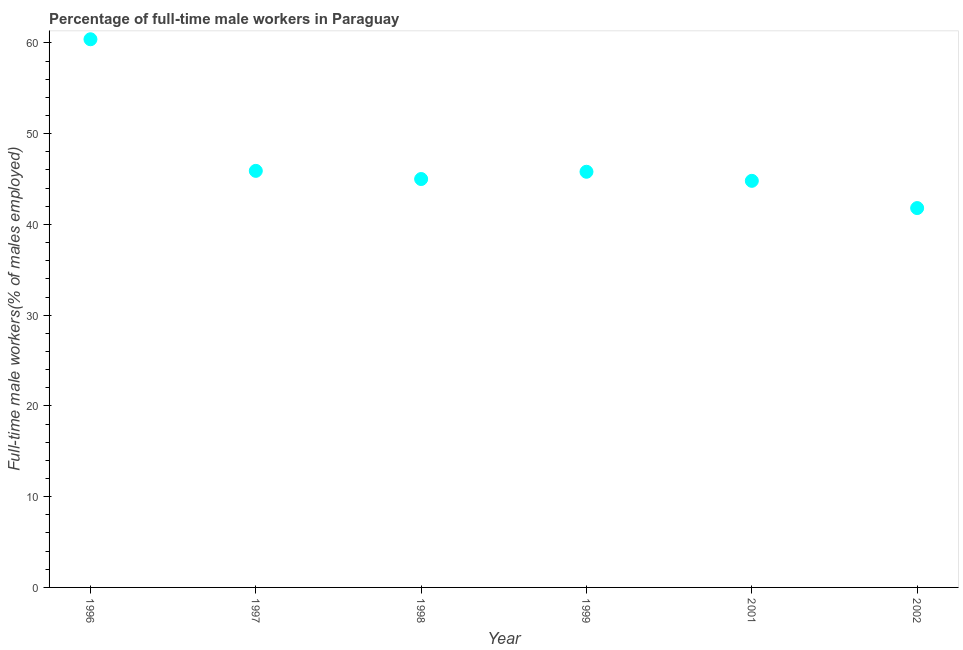What is the percentage of full-time male workers in 1996?
Ensure brevity in your answer.  60.4. Across all years, what is the maximum percentage of full-time male workers?
Provide a short and direct response. 60.4. Across all years, what is the minimum percentage of full-time male workers?
Make the answer very short. 41.8. In which year was the percentage of full-time male workers maximum?
Provide a succinct answer. 1996. What is the sum of the percentage of full-time male workers?
Offer a terse response. 283.7. What is the average percentage of full-time male workers per year?
Offer a terse response. 47.28. What is the median percentage of full-time male workers?
Offer a very short reply. 45.4. Do a majority of the years between 1999 and 2002 (inclusive) have percentage of full-time male workers greater than 14 %?
Keep it short and to the point. Yes. What is the ratio of the percentage of full-time male workers in 2001 to that in 2002?
Your answer should be compact. 1.07. What is the difference between the highest and the second highest percentage of full-time male workers?
Make the answer very short. 14.5. Is the sum of the percentage of full-time male workers in 1997 and 1999 greater than the maximum percentage of full-time male workers across all years?
Offer a terse response. Yes. What is the difference between the highest and the lowest percentage of full-time male workers?
Keep it short and to the point. 18.6. In how many years, is the percentage of full-time male workers greater than the average percentage of full-time male workers taken over all years?
Offer a very short reply. 1. How many dotlines are there?
Your answer should be very brief. 1. How many years are there in the graph?
Give a very brief answer. 6. What is the difference between two consecutive major ticks on the Y-axis?
Make the answer very short. 10. What is the title of the graph?
Ensure brevity in your answer.  Percentage of full-time male workers in Paraguay. What is the label or title of the X-axis?
Provide a short and direct response. Year. What is the label or title of the Y-axis?
Your answer should be compact. Full-time male workers(% of males employed). What is the Full-time male workers(% of males employed) in 1996?
Your answer should be very brief. 60.4. What is the Full-time male workers(% of males employed) in 1997?
Ensure brevity in your answer.  45.9. What is the Full-time male workers(% of males employed) in 1999?
Provide a succinct answer. 45.8. What is the Full-time male workers(% of males employed) in 2001?
Offer a terse response. 44.8. What is the Full-time male workers(% of males employed) in 2002?
Ensure brevity in your answer.  41.8. What is the difference between the Full-time male workers(% of males employed) in 1996 and 1997?
Your answer should be very brief. 14.5. What is the difference between the Full-time male workers(% of males employed) in 1996 and 1999?
Make the answer very short. 14.6. What is the difference between the Full-time male workers(% of males employed) in 1997 and 1999?
Your answer should be compact. 0.1. What is the difference between the Full-time male workers(% of males employed) in 1997 and 2001?
Give a very brief answer. 1.1. What is the difference between the Full-time male workers(% of males employed) in 1998 and 1999?
Provide a short and direct response. -0.8. What is the difference between the Full-time male workers(% of males employed) in 1998 and 2001?
Your answer should be very brief. 0.2. What is the difference between the Full-time male workers(% of males employed) in 1998 and 2002?
Provide a short and direct response. 3.2. What is the difference between the Full-time male workers(% of males employed) in 1999 and 2002?
Make the answer very short. 4. What is the ratio of the Full-time male workers(% of males employed) in 1996 to that in 1997?
Keep it short and to the point. 1.32. What is the ratio of the Full-time male workers(% of males employed) in 1996 to that in 1998?
Keep it short and to the point. 1.34. What is the ratio of the Full-time male workers(% of males employed) in 1996 to that in 1999?
Make the answer very short. 1.32. What is the ratio of the Full-time male workers(% of males employed) in 1996 to that in 2001?
Ensure brevity in your answer.  1.35. What is the ratio of the Full-time male workers(% of males employed) in 1996 to that in 2002?
Your answer should be compact. 1.45. What is the ratio of the Full-time male workers(% of males employed) in 1997 to that in 2002?
Provide a succinct answer. 1.1. What is the ratio of the Full-time male workers(% of males employed) in 1998 to that in 1999?
Offer a very short reply. 0.98. What is the ratio of the Full-time male workers(% of males employed) in 1998 to that in 2001?
Offer a terse response. 1. What is the ratio of the Full-time male workers(% of males employed) in 1998 to that in 2002?
Your answer should be very brief. 1.08. What is the ratio of the Full-time male workers(% of males employed) in 1999 to that in 2001?
Provide a succinct answer. 1.02. What is the ratio of the Full-time male workers(% of males employed) in 1999 to that in 2002?
Keep it short and to the point. 1.1. What is the ratio of the Full-time male workers(% of males employed) in 2001 to that in 2002?
Your answer should be compact. 1.07. 